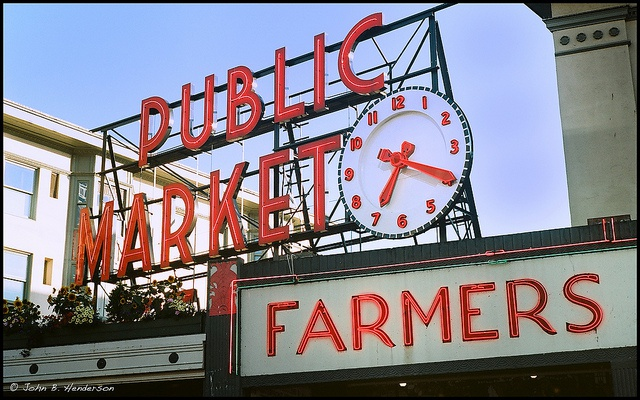Describe the objects in this image and their specific colors. I can see a clock in black, lavender, and salmon tones in this image. 